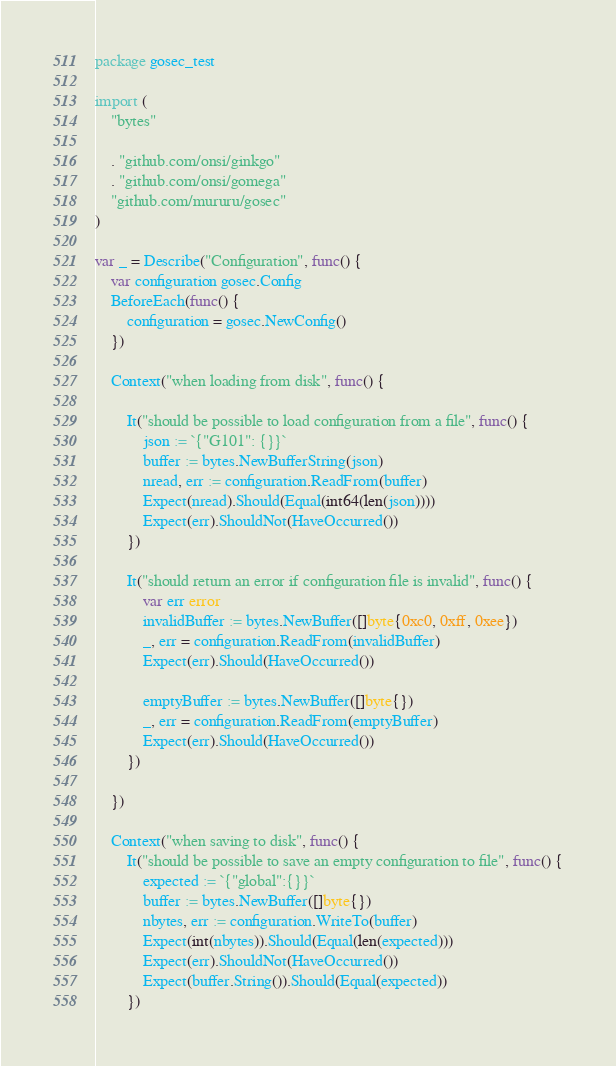Convert code to text. <code><loc_0><loc_0><loc_500><loc_500><_Go_>package gosec_test

import (
	"bytes"

	. "github.com/onsi/ginkgo"
	. "github.com/onsi/gomega"
	"github.com/mururu/gosec"
)

var _ = Describe("Configuration", func() {
	var configuration gosec.Config
	BeforeEach(func() {
		configuration = gosec.NewConfig()
	})

	Context("when loading from disk", func() {

		It("should be possible to load configuration from a file", func() {
			json := `{"G101": {}}`
			buffer := bytes.NewBufferString(json)
			nread, err := configuration.ReadFrom(buffer)
			Expect(nread).Should(Equal(int64(len(json))))
			Expect(err).ShouldNot(HaveOccurred())
		})

		It("should return an error if configuration file is invalid", func() {
			var err error
			invalidBuffer := bytes.NewBuffer([]byte{0xc0, 0xff, 0xee})
			_, err = configuration.ReadFrom(invalidBuffer)
			Expect(err).Should(HaveOccurred())

			emptyBuffer := bytes.NewBuffer([]byte{})
			_, err = configuration.ReadFrom(emptyBuffer)
			Expect(err).Should(HaveOccurred())
		})

	})

	Context("when saving to disk", func() {
		It("should be possible to save an empty configuration to file", func() {
			expected := `{"global":{}}`
			buffer := bytes.NewBuffer([]byte{})
			nbytes, err := configuration.WriteTo(buffer)
			Expect(int(nbytes)).Should(Equal(len(expected)))
			Expect(err).ShouldNot(HaveOccurred())
			Expect(buffer.String()).Should(Equal(expected))
		})
</code> 